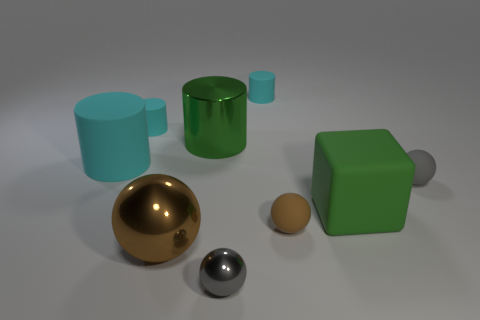Subtract all cyan cylinders. How many were subtracted if there are1cyan cylinders left? 2 Subtract all large brown balls. How many balls are left? 3 Subtract all gray spheres. How many spheres are left? 2 Subtract all cubes. How many objects are left? 8 Subtract 1 balls. How many balls are left? 3 Subtract all purple balls. How many green cylinders are left? 1 Subtract 0 yellow balls. How many objects are left? 9 Subtract all gray balls. Subtract all green cylinders. How many balls are left? 2 Subtract all small yellow matte objects. Subtract all big green objects. How many objects are left? 7 Add 8 large brown shiny balls. How many large brown shiny balls are left? 9 